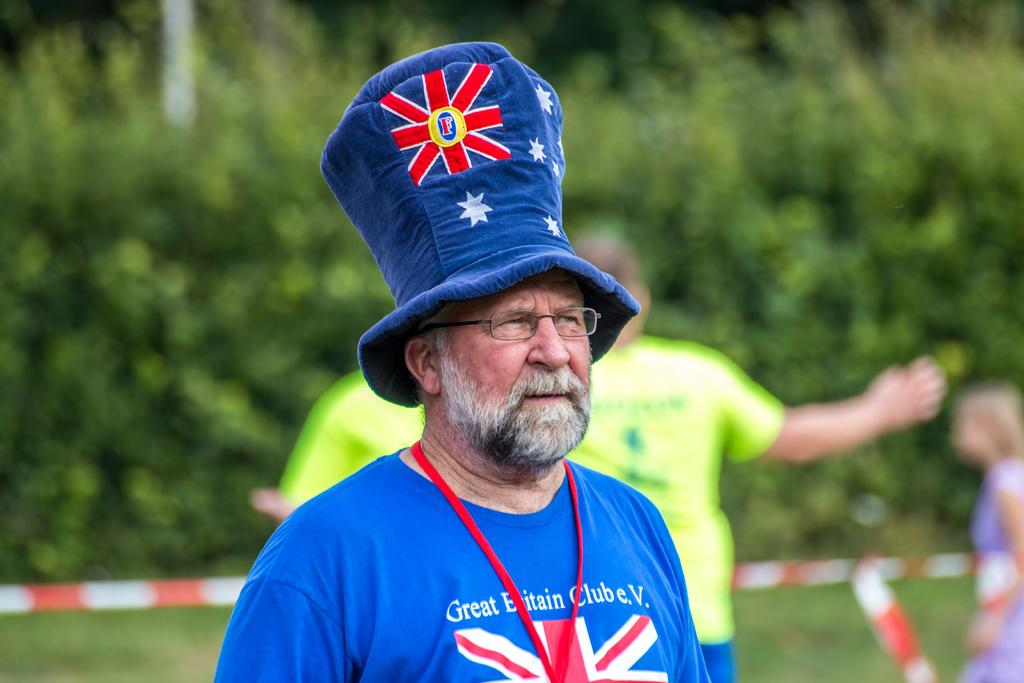<image>
Give a short and clear explanation of the subsequent image. A middle-age man wears a tall hat and a t-shirt for the Great Britain Club. 